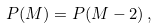Convert formula to latex. <formula><loc_0><loc_0><loc_500><loc_500>P ( M ) = P ( M - 2 ) \, ,</formula> 